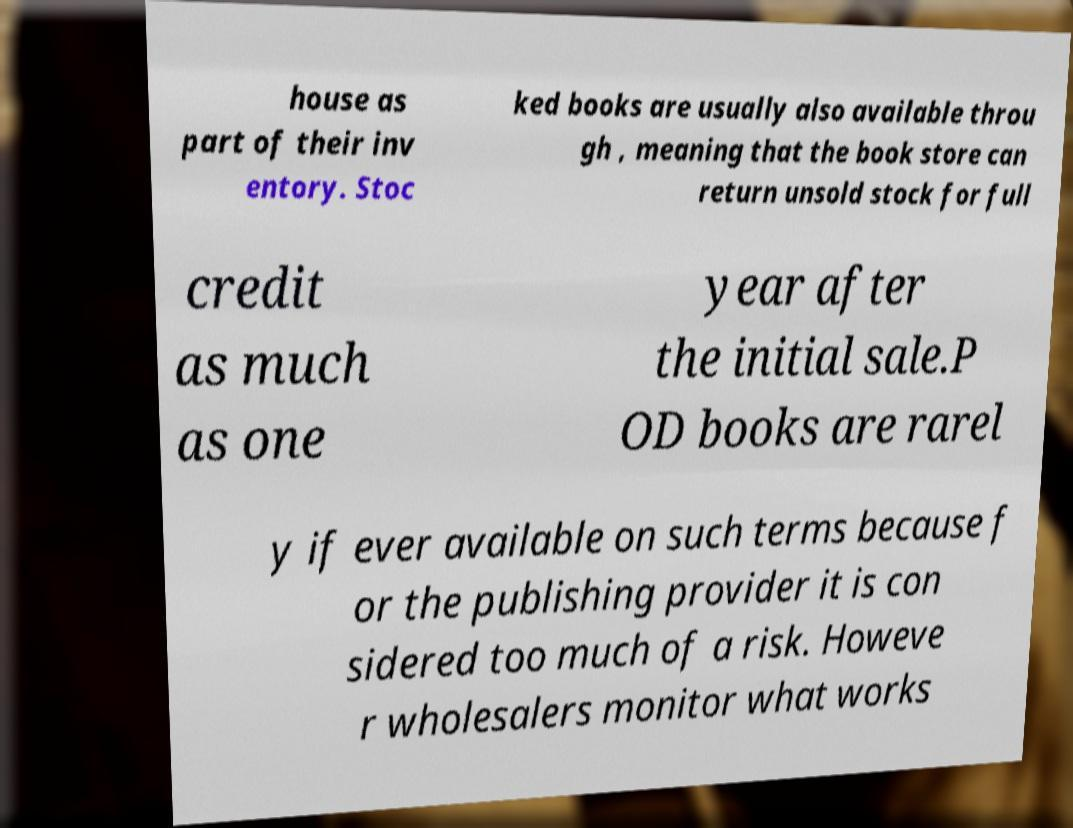Could you extract and type out the text from this image? house as part of their inv entory. Stoc ked books are usually also available throu gh , meaning that the book store can return unsold stock for full credit as much as one year after the initial sale.P OD books are rarel y if ever available on such terms because f or the publishing provider it is con sidered too much of a risk. Howeve r wholesalers monitor what works 